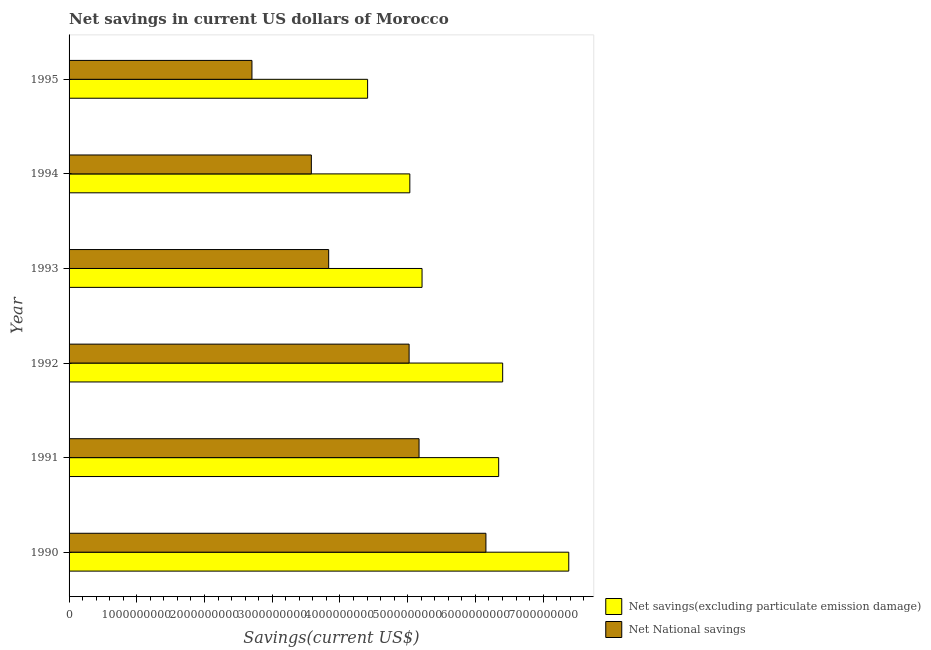How many different coloured bars are there?
Your answer should be compact. 2. Are the number of bars per tick equal to the number of legend labels?
Keep it short and to the point. Yes. Are the number of bars on each tick of the Y-axis equal?
Ensure brevity in your answer.  Yes. How many bars are there on the 6th tick from the top?
Make the answer very short. 2. What is the net national savings in 1993?
Make the answer very short. 3.83e+09. Across all years, what is the maximum net savings(excluding particulate emission damage)?
Give a very brief answer. 7.38e+09. Across all years, what is the minimum net national savings?
Offer a terse response. 2.70e+09. In which year was the net national savings minimum?
Your answer should be compact. 1995. What is the total net national savings in the graph?
Your response must be concise. 2.65e+1. What is the difference between the net national savings in 1993 and that in 1995?
Make the answer very short. 1.13e+09. What is the difference between the net savings(excluding particulate emission damage) in 1995 and the net national savings in 1992?
Offer a terse response. -6.13e+08. What is the average net savings(excluding particulate emission damage) per year?
Provide a short and direct response. 5.80e+09. In the year 1990, what is the difference between the net national savings and net savings(excluding particulate emission damage)?
Provide a succinct answer. -1.22e+09. In how many years, is the net savings(excluding particulate emission damage) greater than 4800000000 US$?
Your answer should be compact. 5. What is the ratio of the net national savings in 1993 to that in 1994?
Your response must be concise. 1.07. What is the difference between the highest and the second highest net savings(excluding particulate emission damage)?
Make the answer very short. 9.76e+08. What is the difference between the highest and the lowest net savings(excluding particulate emission damage)?
Offer a terse response. 2.97e+09. In how many years, is the net national savings greater than the average net national savings taken over all years?
Offer a terse response. 3. What does the 1st bar from the top in 1995 represents?
Offer a very short reply. Net National savings. What does the 2nd bar from the bottom in 1995 represents?
Your answer should be very brief. Net National savings. How many years are there in the graph?
Give a very brief answer. 6. Are the values on the major ticks of X-axis written in scientific E-notation?
Make the answer very short. No. Does the graph contain grids?
Provide a short and direct response. No. How many legend labels are there?
Provide a succinct answer. 2. How are the legend labels stacked?
Offer a very short reply. Vertical. What is the title of the graph?
Your answer should be very brief. Net savings in current US dollars of Morocco. What is the label or title of the X-axis?
Your answer should be very brief. Savings(current US$). What is the Savings(current US$) of Net savings(excluding particulate emission damage) in 1990?
Your response must be concise. 7.38e+09. What is the Savings(current US$) in Net National savings in 1990?
Your response must be concise. 6.15e+09. What is the Savings(current US$) in Net savings(excluding particulate emission damage) in 1991?
Your response must be concise. 6.34e+09. What is the Savings(current US$) of Net National savings in 1991?
Your answer should be compact. 5.17e+09. What is the Savings(current US$) in Net savings(excluding particulate emission damage) in 1992?
Your answer should be very brief. 6.40e+09. What is the Savings(current US$) in Net National savings in 1992?
Give a very brief answer. 5.02e+09. What is the Savings(current US$) of Net savings(excluding particulate emission damage) in 1993?
Your answer should be compact. 5.21e+09. What is the Savings(current US$) in Net National savings in 1993?
Your answer should be compact. 3.83e+09. What is the Savings(current US$) in Net savings(excluding particulate emission damage) in 1994?
Keep it short and to the point. 5.03e+09. What is the Savings(current US$) in Net National savings in 1994?
Offer a terse response. 3.58e+09. What is the Savings(current US$) of Net savings(excluding particulate emission damage) in 1995?
Give a very brief answer. 4.41e+09. What is the Savings(current US$) in Net National savings in 1995?
Provide a short and direct response. 2.70e+09. Across all years, what is the maximum Savings(current US$) of Net savings(excluding particulate emission damage)?
Offer a terse response. 7.38e+09. Across all years, what is the maximum Savings(current US$) of Net National savings?
Offer a very short reply. 6.15e+09. Across all years, what is the minimum Savings(current US$) in Net savings(excluding particulate emission damage)?
Give a very brief answer. 4.41e+09. Across all years, what is the minimum Savings(current US$) of Net National savings?
Keep it short and to the point. 2.70e+09. What is the total Savings(current US$) in Net savings(excluding particulate emission damage) in the graph?
Give a very brief answer. 3.48e+1. What is the total Savings(current US$) in Net National savings in the graph?
Your answer should be compact. 2.65e+1. What is the difference between the Savings(current US$) in Net savings(excluding particulate emission damage) in 1990 and that in 1991?
Ensure brevity in your answer.  1.03e+09. What is the difference between the Savings(current US$) of Net National savings in 1990 and that in 1991?
Provide a succinct answer. 9.88e+08. What is the difference between the Savings(current US$) of Net savings(excluding particulate emission damage) in 1990 and that in 1992?
Your answer should be compact. 9.76e+08. What is the difference between the Savings(current US$) of Net National savings in 1990 and that in 1992?
Your answer should be compact. 1.13e+09. What is the difference between the Savings(current US$) in Net savings(excluding particulate emission damage) in 1990 and that in 1993?
Ensure brevity in your answer.  2.17e+09. What is the difference between the Savings(current US$) of Net National savings in 1990 and that in 1993?
Offer a terse response. 2.32e+09. What is the difference between the Savings(current US$) of Net savings(excluding particulate emission damage) in 1990 and that in 1994?
Your answer should be compact. 2.35e+09. What is the difference between the Savings(current US$) in Net National savings in 1990 and that in 1994?
Offer a terse response. 2.58e+09. What is the difference between the Savings(current US$) in Net savings(excluding particulate emission damage) in 1990 and that in 1995?
Give a very brief answer. 2.97e+09. What is the difference between the Savings(current US$) of Net National savings in 1990 and that in 1995?
Your response must be concise. 3.45e+09. What is the difference between the Savings(current US$) of Net savings(excluding particulate emission damage) in 1991 and that in 1992?
Offer a terse response. -5.90e+07. What is the difference between the Savings(current US$) of Net National savings in 1991 and that in 1992?
Offer a very short reply. 1.47e+08. What is the difference between the Savings(current US$) of Net savings(excluding particulate emission damage) in 1991 and that in 1993?
Provide a succinct answer. 1.13e+09. What is the difference between the Savings(current US$) in Net National savings in 1991 and that in 1993?
Offer a terse response. 1.33e+09. What is the difference between the Savings(current US$) in Net savings(excluding particulate emission damage) in 1991 and that in 1994?
Your response must be concise. 1.31e+09. What is the difference between the Savings(current US$) of Net National savings in 1991 and that in 1994?
Offer a terse response. 1.59e+09. What is the difference between the Savings(current US$) in Net savings(excluding particulate emission damage) in 1991 and that in 1995?
Provide a short and direct response. 1.94e+09. What is the difference between the Savings(current US$) in Net National savings in 1991 and that in 1995?
Give a very brief answer. 2.47e+09. What is the difference between the Savings(current US$) of Net savings(excluding particulate emission damage) in 1992 and that in 1993?
Offer a very short reply. 1.19e+09. What is the difference between the Savings(current US$) in Net National savings in 1992 and that in 1993?
Make the answer very short. 1.19e+09. What is the difference between the Savings(current US$) of Net savings(excluding particulate emission damage) in 1992 and that in 1994?
Your response must be concise. 1.37e+09. What is the difference between the Savings(current US$) of Net National savings in 1992 and that in 1994?
Offer a very short reply. 1.44e+09. What is the difference between the Savings(current US$) in Net savings(excluding particulate emission damage) in 1992 and that in 1995?
Offer a terse response. 1.99e+09. What is the difference between the Savings(current US$) in Net National savings in 1992 and that in 1995?
Offer a terse response. 2.32e+09. What is the difference between the Savings(current US$) in Net savings(excluding particulate emission damage) in 1993 and that in 1994?
Provide a succinct answer. 1.80e+08. What is the difference between the Savings(current US$) in Net National savings in 1993 and that in 1994?
Keep it short and to the point. 2.56e+08. What is the difference between the Savings(current US$) in Net savings(excluding particulate emission damage) in 1993 and that in 1995?
Provide a succinct answer. 8.04e+08. What is the difference between the Savings(current US$) in Net National savings in 1993 and that in 1995?
Your response must be concise. 1.13e+09. What is the difference between the Savings(current US$) of Net savings(excluding particulate emission damage) in 1994 and that in 1995?
Offer a very short reply. 6.23e+08. What is the difference between the Savings(current US$) in Net National savings in 1994 and that in 1995?
Make the answer very short. 8.77e+08. What is the difference between the Savings(current US$) in Net savings(excluding particulate emission damage) in 1990 and the Savings(current US$) in Net National savings in 1991?
Provide a short and direct response. 2.21e+09. What is the difference between the Savings(current US$) in Net savings(excluding particulate emission damage) in 1990 and the Savings(current US$) in Net National savings in 1992?
Give a very brief answer. 2.36e+09. What is the difference between the Savings(current US$) in Net savings(excluding particulate emission damage) in 1990 and the Savings(current US$) in Net National savings in 1993?
Give a very brief answer. 3.54e+09. What is the difference between the Savings(current US$) in Net savings(excluding particulate emission damage) in 1990 and the Savings(current US$) in Net National savings in 1994?
Provide a short and direct response. 3.80e+09. What is the difference between the Savings(current US$) of Net savings(excluding particulate emission damage) in 1990 and the Savings(current US$) of Net National savings in 1995?
Give a very brief answer. 4.68e+09. What is the difference between the Savings(current US$) in Net savings(excluding particulate emission damage) in 1991 and the Savings(current US$) in Net National savings in 1992?
Make the answer very short. 1.32e+09. What is the difference between the Savings(current US$) of Net savings(excluding particulate emission damage) in 1991 and the Savings(current US$) of Net National savings in 1993?
Ensure brevity in your answer.  2.51e+09. What is the difference between the Savings(current US$) in Net savings(excluding particulate emission damage) in 1991 and the Savings(current US$) in Net National savings in 1994?
Give a very brief answer. 2.77e+09. What is the difference between the Savings(current US$) of Net savings(excluding particulate emission damage) in 1991 and the Savings(current US$) of Net National savings in 1995?
Your response must be concise. 3.64e+09. What is the difference between the Savings(current US$) in Net savings(excluding particulate emission damage) in 1992 and the Savings(current US$) in Net National savings in 1993?
Offer a very short reply. 2.57e+09. What is the difference between the Savings(current US$) in Net savings(excluding particulate emission damage) in 1992 and the Savings(current US$) in Net National savings in 1994?
Ensure brevity in your answer.  2.82e+09. What is the difference between the Savings(current US$) of Net savings(excluding particulate emission damage) in 1992 and the Savings(current US$) of Net National savings in 1995?
Your answer should be very brief. 3.70e+09. What is the difference between the Savings(current US$) in Net savings(excluding particulate emission damage) in 1993 and the Savings(current US$) in Net National savings in 1994?
Your answer should be very brief. 1.63e+09. What is the difference between the Savings(current US$) in Net savings(excluding particulate emission damage) in 1993 and the Savings(current US$) in Net National savings in 1995?
Make the answer very short. 2.51e+09. What is the difference between the Savings(current US$) in Net savings(excluding particulate emission damage) in 1994 and the Savings(current US$) in Net National savings in 1995?
Provide a succinct answer. 2.33e+09. What is the average Savings(current US$) of Net savings(excluding particulate emission damage) per year?
Provide a short and direct response. 5.80e+09. What is the average Savings(current US$) in Net National savings per year?
Keep it short and to the point. 4.41e+09. In the year 1990, what is the difference between the Savings(current US$) of Net savings(excluding particulate emission damage) and Savings(current US$) of Net National savings?
Keep it short and to the point. 1.22e+09. In the year 1991, what is the difference between the Savings(current US$) of Net savings(excluding particulate emission damage) and Savings(current US$) of Net National savings?
Your response must be concise. 1.18e+09. In the year 1992, what is the difference between the Savings(current US$) of Net savings(excluding particulate emission damage) and Savings(current US$) of Net National savings?
Make the answer very short. 1.38e+09. In the year 1993, what is the difference between the Savings(current US$) in Net savings(excluding particulate emission damage) and Savings(current US$) in Net National savings?
Keep it short and to the point. 1.38e+09. In the year 1994, what is the difference between the Savings(current US$) in Net savings(excluding particulate emission damage) and Savings(current US$) in Net National savings?
Ensure brevity in your answer.  1.45e+09. In the year 1995, what is the difference between the Savings(current US$) of Net savings(excluding particulate emission damage) and Savings(current US$) of Net National savings?
Give a very brief answer. 1.71e+09. What is the ratio of the Savings(current US$) of Net savings(excluding particulate emission damage) in 1990 to that in 1991?
Your answer should be compact. 1.16. What is the ratio of the Savings(current US$) of Net National savings in 1990 to that in 1991?
Your response must be concise. 1.19. What is the ratio of the Savings(current US$) of Net savings(excluding particulate emission damage) in 1990 to that in 1992?
Your answer should be very brief. 1.15. What is the ratio of the Savings(current US$) of Net National savings in 1990 to that in 1992?
Keep it short and to the point. 1.23. What is the ratio of the Savings(current US$) of Net savings(excluding particulate emission damage) in 1990 to that in 1993?
Your answer should be very brief. 1.42. What is the ratio of the Savings(current US$) in Net National savings in 1990 to that in 1993?
Offer a very short reply. 1.61. What is the ratio of the Savings(current US$) in Net savings(excluding particulate emission damage) in 1990 to that in 1994?
Make the answer very short. 1.47. What is the ratio of the Savings(current US$) in Net National savings in 1990 to that in 1994?
Offer a very short reply. 1.72. What is the ratio of the Savings(current US$) of Net savings(excluding particulate emission damage) in 1990 to that in 1995?
Give a very brief answer. 1.67. What is the ratio of the Savings(current US$) of Net National savings in 1990 to that in 1995?
Provide a succinct answer. 2.28. What is the ratio of the Savings(current US$) in Net savings(excluding particulate emission damage) in 1991 to that in 1992?
Your answer should be very brief. 0.99. What is the ratio of the Savings(current US$) in Net National savings in 1991 to that in 1992?
Provide a short and direct response. 1.03. What is the ratio of the Savings(current US$) of Net savings(excluding particulate emission damage) in 1991 to that in 1993?
Provide a short and direct response. 1.22. What is the ratio of the Savings(current US$) of Net National savings in 1991 to that in 1993?
Your response must be concise. 1.35. What is the ratio of the Savings(current US$) of Net savings(excluding particulate emission damage) in 1991 to that in 1994?
Provide a succinct answer. 1.26. What is the ratio of the Savings(current US$) in Net National savings in 1991 to that in 1994?
Your response must be concise. 1.44. What is the ratio of the Savings(current US$) of Net savings(excluding particulate emission damage) in 1991 to that in 1995?
Provide a succinct answer. 1.44. What is the ratio of the Savings(current US$) of Net National savings in 1991 to that in 1995?
Your response must be concise. 1.91. What is the ratio of the Savings(current US$) in Net savings(excluding particulate emission damage) in 1992 to that in 1993?
Provide a succinct answer. 1.23. What is the ratio of the Savings(current US$) of Net National savings in 1992 to that in 1993?
Offer a terse response. 1.31. What is the ratio of the Savings(current US$) of Net savings(excluding particulate emission damage) in 1992 to that in 1994?
Provide a succinct answer. 1.27. What is the ratio of the Savings(current US$) in Net National savings in 1992 to that in 1994?
Ensure brevity in your answer.  1.4. What is the ratio of the Savings(current US$) of Net savings(excluding particulate emission damage) in 1992 to that in 1995?
Your response must be concise. 1.45. What is the ratio of the Savings(current US$) in Net National savings in 1992 to that in 1995?
Provide a short and direct response. 1.86. What is the ratio of the Savings(current US$) in Net savings(excluding particulate emission damage) in 1993 to that in 1994?
Ensure brevity in your answer.  1.04. What is the ratio of the Savings(current US$) of Net National savings in 1993 to that in 1994?
Your answer should be very brief. 1.07. What is the ratio of the Savings(current US$) of Net savings(excluding particulate emission damage) in 1993 to that in 1995?
Your answer should be very brief. 1.18. What is the ratio of the Savings(current US$) in Net National savings in 1993 to that in 1995?
Keep it short and to the point. 1.42. What is the ratio of the Savings(current US$) in Net savings(excluding particulate emission damage) in 1994 to that in 1995?
Give a very brief answer. 1.14. What is the ratio of the Savings(current US$) of Net National savings in 1994 to that in 1995?
Your response must be concise. 1.32. What is the difference between the highest and the second highest Savings(current US$) in Net savings(excluding particulate emission damage)?
Make the answer very short. 9.76e+08. What is the difference between the highest and the second highest Savings(current US$) in Net National savings?
Keep it short and to the point. 9.88e+08. What is the difference between the highest and the lowest Savings(current US$) in Net savings(excluding particulate emission damage)?
Offer a very short reply. 2.97e+09. What is the difference between the highest and the lowest Savings(current US$) in Net National savings?
Your answer should be compact. 3.45e+09. 